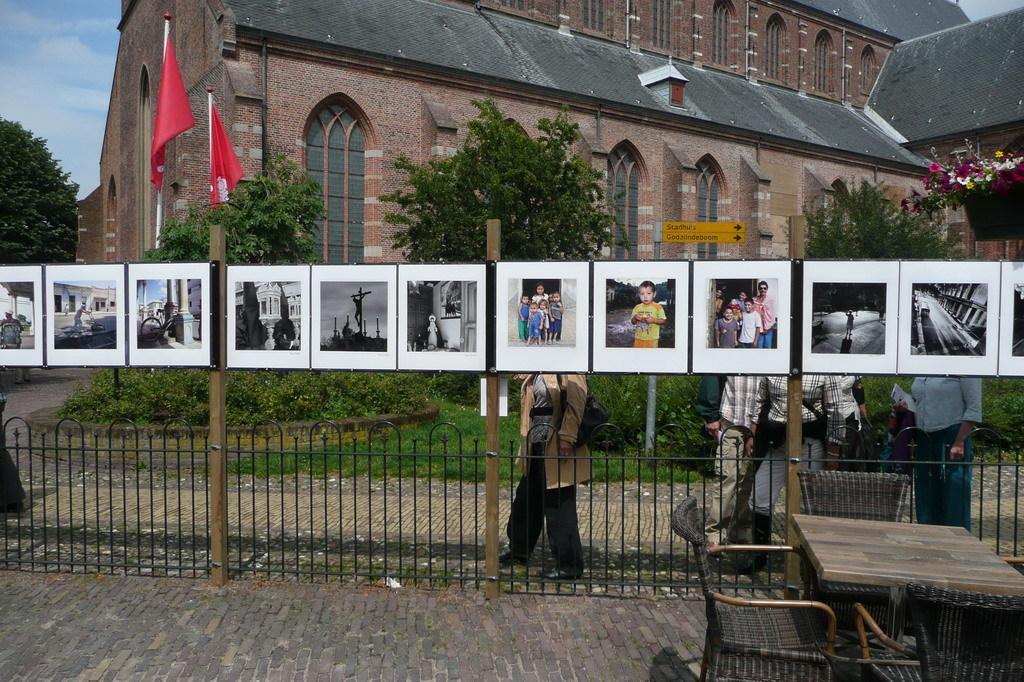Can you describe this image briefly? In this image we can see the photo frames. Here we can see the metal fence at the bottom. Here we can see the table and chair arrangement on the bottom right side. In the background, we can see the building and trees. Here we can see the flag poles. Here we can see the flower pot on the top right side. This is a sky with clouds. 